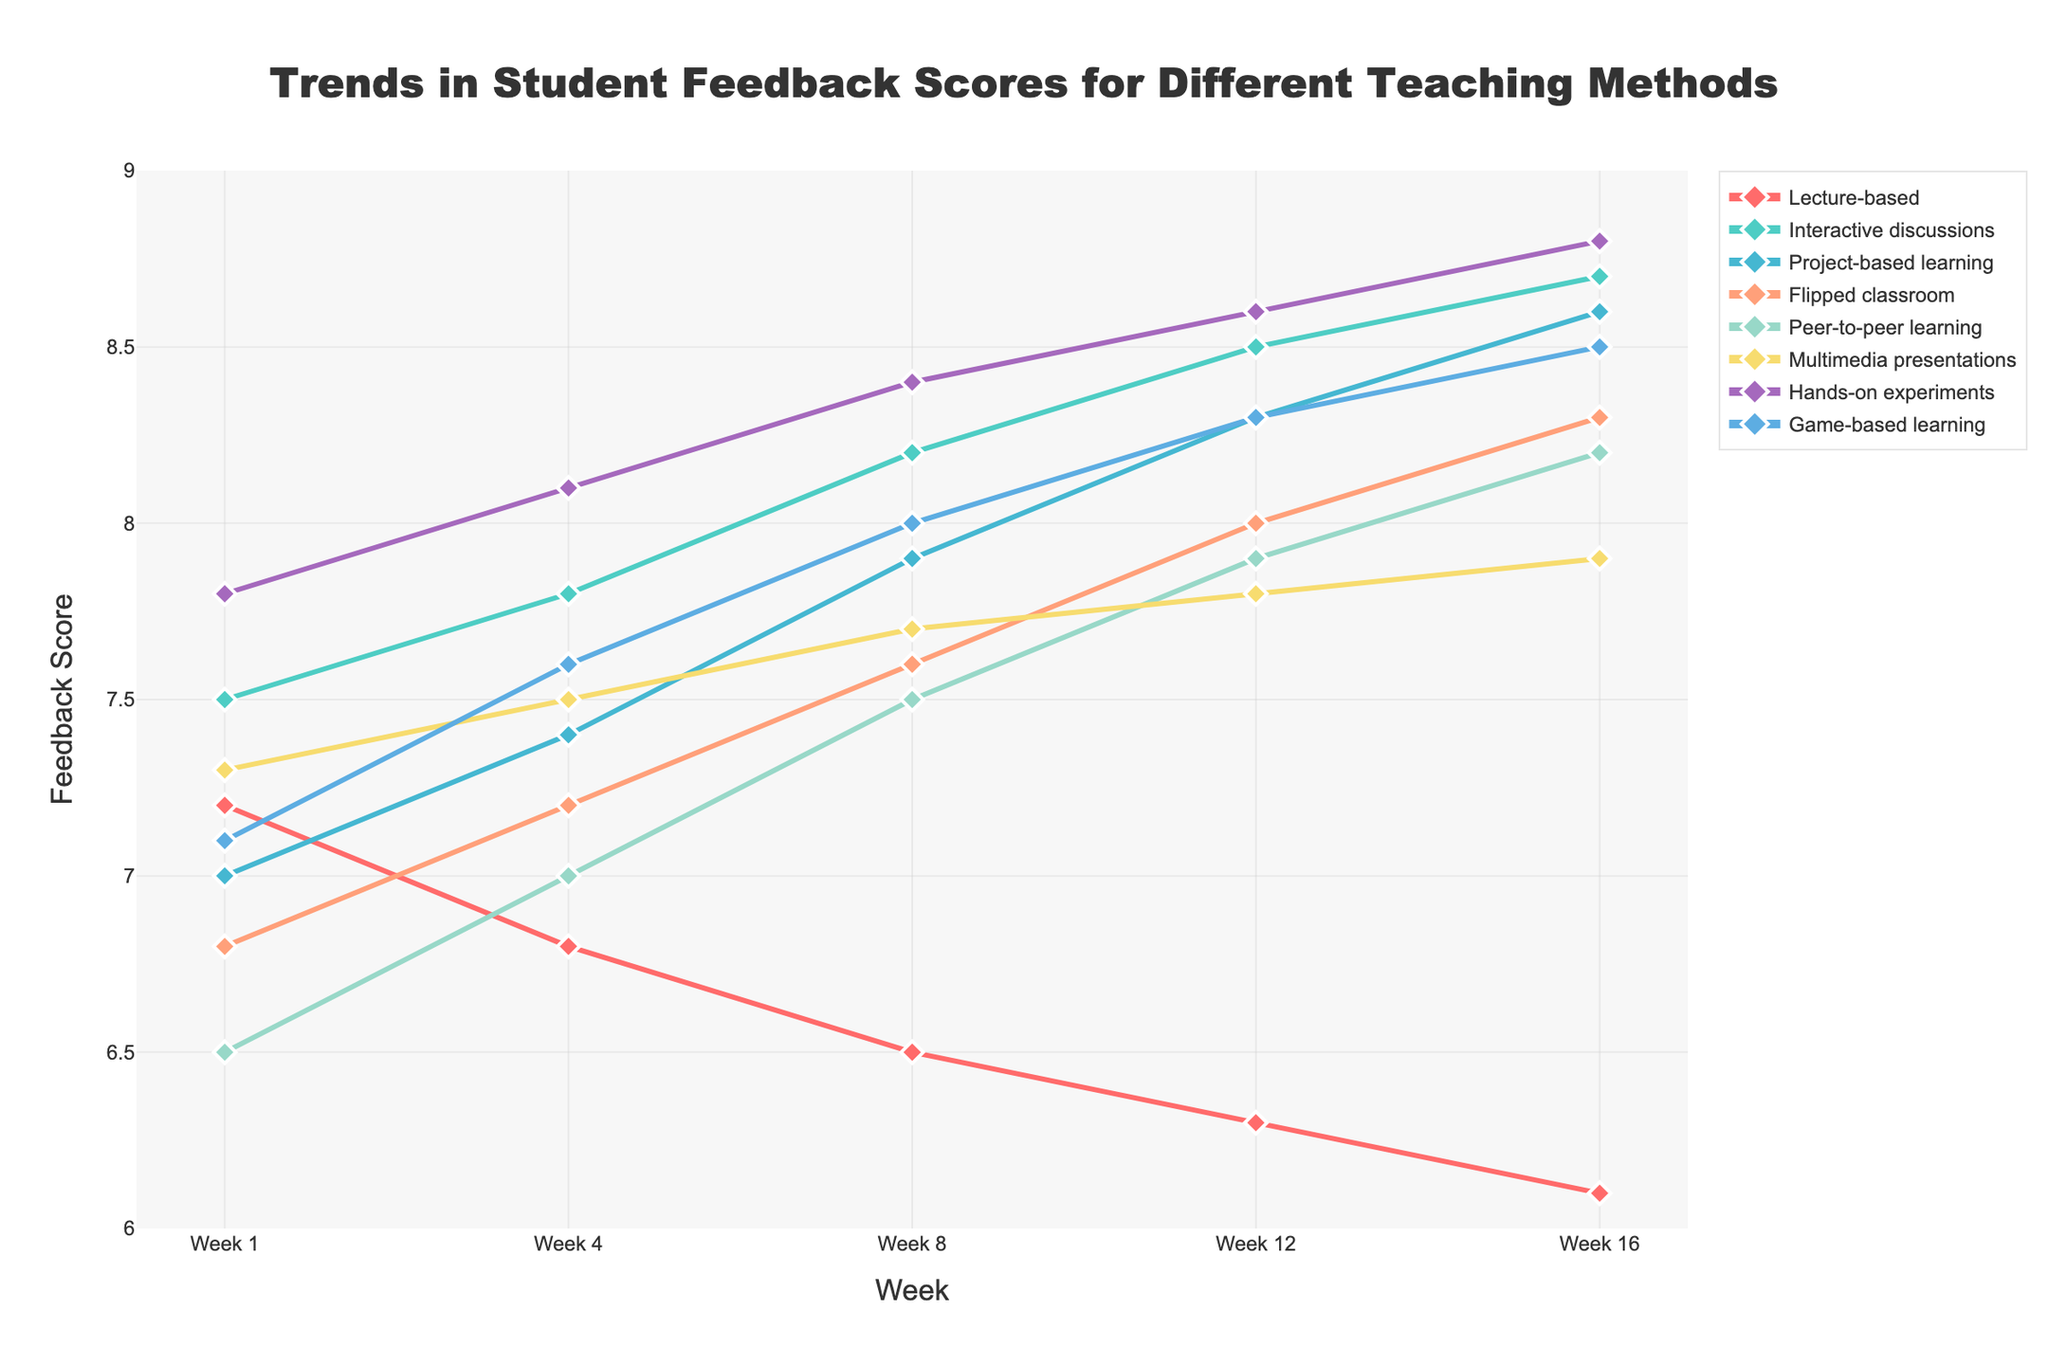What's the general trend for feedback scores of the 'Interactive discussions' teaching method over the semester? The feedback scores for the 'Interactive discussions' teaching method generally increase over the weeks, starting from 7.5 in Week 1 and reaching 8.7 by Week 16. This shows a consistent upward trend.
Answer: Increasing Which teaching method had the highest feedback score in Week 16? In Week 16, the 'Hands-on experiments' teaching method had the highest feedback score, which is 8.8. This can be seen by looking at the peak point in the last column of the chart.
Answer: Hands-on experiments How does the feedback score for 'Lecture-based' teaching method change from Week 1 to Week 16? The feedback score for the 'Lecture-based' teaching method decreases over the semester, starting at 7.2 in Week 1 and going down to 6.1 in Week 16. This indicates a consistent decline.
Answer: Decreases Compare the feedback scores of 'Game-based learning' and 'Project-based learning' in Week 8. Which one received higher feedback? In Week 8, 'Project-based learning' has a feedback score of 7.9, while 'Game-based learning' has a feedback score of 8.0. Therefore, 'Game-based learning' received higher feedback.
Answer: Game-based learning Calculate the average feedback score for the 'Flipped classroom' teaching method over the entire semester. The scores for 'Flipped classroom' over the weeks are 6.8, 7.2, 7.6, 8.0, and 8.3. Adding these up: 6.8 + 7.2 + 7.6 + 8.0 + 8.3 = 37.9. Dividing by the number of weeks (5), the average score is 37.9 / 5 = 7.58.
Answer: 7.58 By how many points did the feedback score for 'Peer-to-peer learning' increase from Week 1 to Week 16? The feedback score for 'Peer-to-peer learning' in Week 1 is 6.5 and in Week 16 it is 8.2. The increase is calculated by 8.2 - 6.5 = 1.7 points.
Answer: 1.7 Which teaching method showed the least change in feedback scores over the semester? The 'Multimedia presentations' teaching method had scores of 7.3, 7.5, 7.7, 7.8, and 7.9 over the weeks. The total change is 7.9 - 7.3 = 0.6. This is the smallest change compared to other methods.
Answer: Multimedia presentations During Week 12, which teaching method had the lowest feedback score? In Week 12, the 'Lecture-based' teaching method had the lowest feedback score, which is 6.3. This can be observed as the lowest point on the chart in that week.
Answer: Lecture-based 